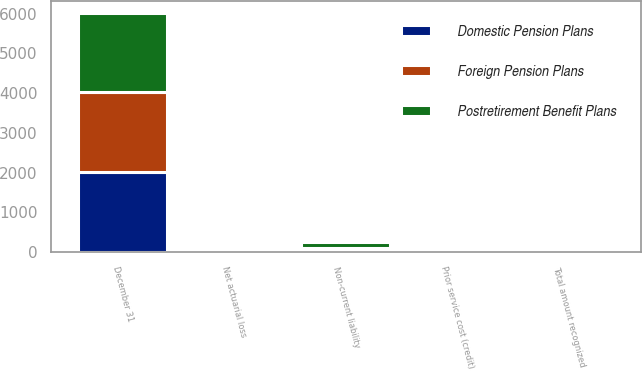Convert chart. <chart><loc_0><loc_0><loc_500><loc_500><stacked_bar_chart><ecel><fcel>December 31<fcel>Non-current liability<fcel>Net actuarial loss<fcel>Prior service cost (credit)<fcel>Total amount recognized<nl><fcel>Foreign Pension Plans<fcel>2008<fcel>46.2<fcel>74.3<fcel>0.2<fcel>74.5<nl><fcel>Postretirement Benefit Plans<fcel>2008<fcel>157.8<fcel>53.4<fcel>2.6<fcel>56.1<nl><fcel>Domestic Pension Plans<fcel>2008<fcel>52.3<fcel>8.1<fcel>0.7<fcel>8<nl></chart> 